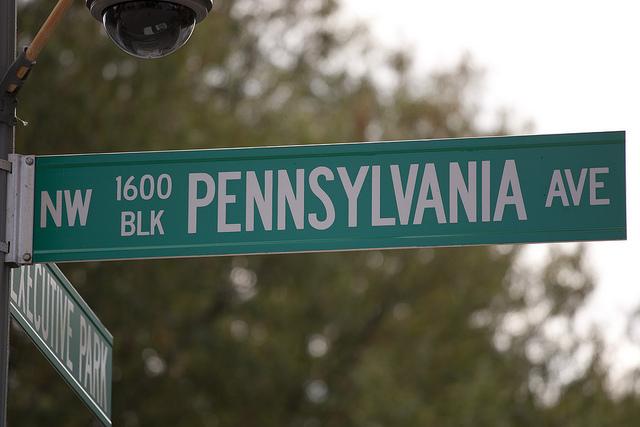How many sets of double letters are on this street sign?
Short answer required. 1. What country is this?
Concise answer only. Usa. What is the name of the street?
Be succinct. Pennsylvania ave. Where is the White House?
Keep it brief. 1600 pennsylvania ave. What is the black thing above the street sign?
Short answer required. Camera. What is the name of the street that intersects Pennsylvania Ave?
Quick response, please. Executive park. What avenue is this?
Quick response, please. Pennsylvania. 